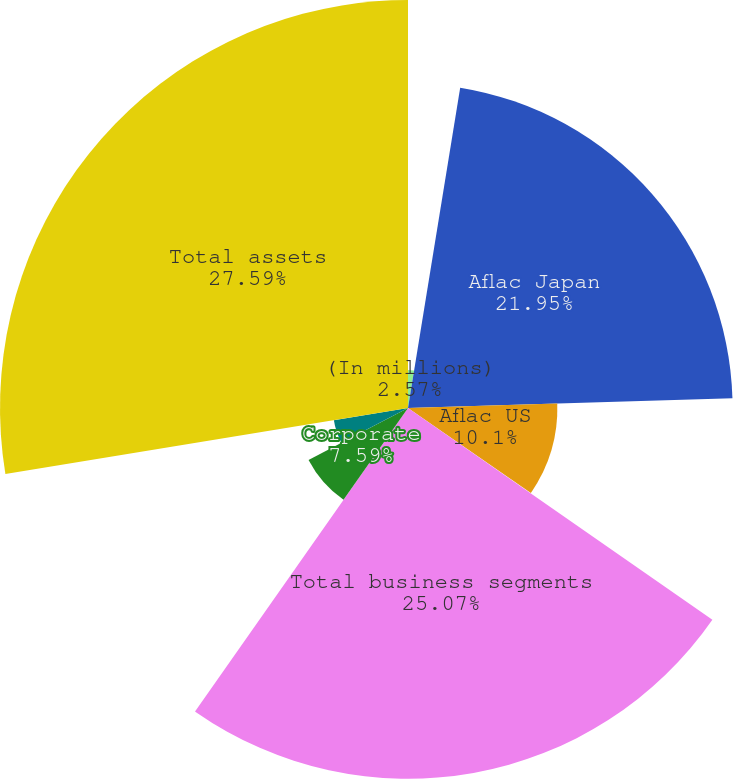Convert chart to OTSL. <chart><loc_0><loc_0><loc_500><loc_500><pie_chart><fcel>(In millions)<fcel>Aflac Japan<fcel>Aflac US<fcel>Other business segments<fcel>Total business segments<fcel>Corporate<fcel>Intercompany eliminations<fcel>Total assets<nl><fcel>2.57%<fcel>21.95%<fcel>10.1%<fcel>0.05%<fcel>25.07%<fcel>7.59%<fcel>5.08%<fcel>27.59%<nl></chart> 